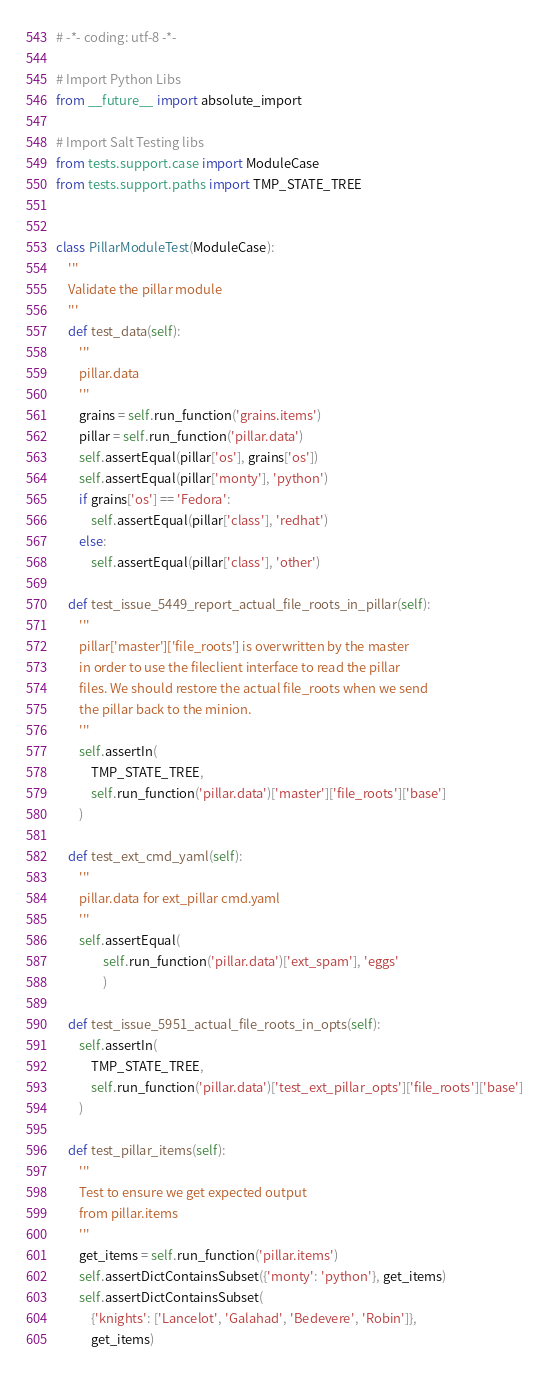Convert code to text. <code><loc_0><loc_0><loc_500><loc_500><_Python_># -*- coding: utf-8 -*-

# Import Python Libs
from __future__ import absolute_import

# Import Salt Testing libs
from tests.support.case import ModuleCase
from tests.support.paths import TMP_STATE_TREE


class PillarModuleTest(ModuleCase):
    '''
    Validate the pillar module
    '''
    def test_data(self):
        '''
        pillar.data
        '''
        grains = self.run_function('grains.items')
        pillar = self.run_function('pillar.data')
        self.assertEqual(pillar['os'], grains['os'])
        self.assertEqual(pillar['monty'], 'python')
        if grains['os'] == 'Fedora':
            self.assertEqual(pillar['class'], 'redhat')
        else:
            self.assertEqual(pillar['class'], 'other')

    def test_issue_5449_report_actual_file_roots_in_pillar(self):
        '''
        pillar['master']['file_roots'] is overwritten by the master
        in order to use the fileclient interface to read the pillar
        files. We should restore the actual file_roots when we send
        the pillar back to the minion.
        '''
        self.assertIn(
            TMP_STATE_TREE,
            self.run_function('pillar.data')['master']['file_roots']['base']
        )

    def test_ext_cmd_yaml(self):
        '''
        pillar.data for ext_pillar cmd.yaml
        '''
        self.assertEqual(
                self.run_function('pillar.data')['ext_spam'], 'eggs'
                )

    def test_issue_5951_actual_file_roots_in_opts(self):
        self.assertIn(
            TMP_STATE_TREE,
            self.run_function('pillar.data')['test_ext_pillar_opts']['file_roots']['base']
        )

    def test_pillar_items(self):
        '''
        Test to ensure we get expected output
        from pillar.items
        '''
        get_items = self.run_function('pillar.items')
        self.assertDictContainsSubset({'monty': 'python'}, get_items)
        self.assertDictContainsSubset(
            {'knights': ['Lancelot', 'Galahad', 'Bedevere', 'Robin']},
            get_items)
</code> 